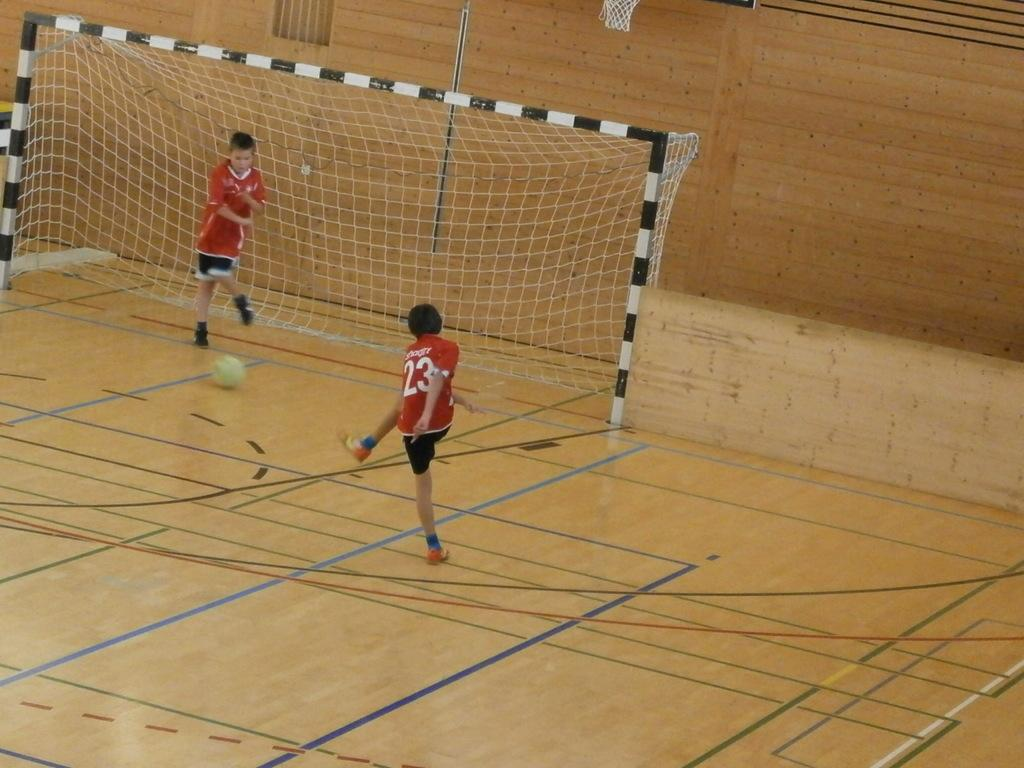<image>
Present a compact description of the photo's key features. A player with the number 23 on his jersey is standing near a net. 